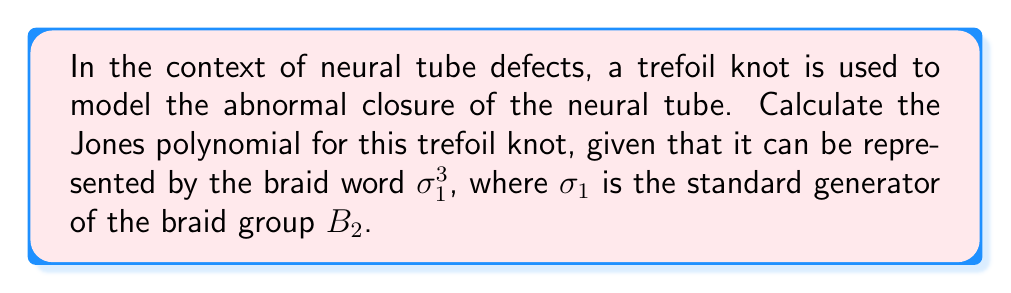Solve this math problem. To calculate the Jones polynomial for the trefoil knot representing neural tube defects, we'll follow these steps:

1) The trefoil knot is represented by the braid word $\sigma_1^3$. This means we're dealing with a 2-strand braid with 3 positive crossings.

2) The Jones polynomial can be calculated using the Kauffman bracket polynomial and the writhe of the knot. Let's start with the Kauffman bracket.

3) The Kauffman bracket of a positive crossing is given by:
   $$\langle \crossingpos \rangle = A\langle \smoothing \rangle + A^{-1}\langle \hsmoothing \rangle$$

4) For our trefoil with 3 positive crossings, we apply this relation three times:
   $$\langle \trefoil \rangle = A^3\langle \circle \rangle + A\langle \infty \rangle + A^{-1}\langle \infty \rangle + A^{-3}\langle \circle \circle \rangle$$

5) Simplify using the rules $\langle \circle \rangle = -A^2 - A^{-2}$ and $\langle \circle \circle \rangle = (-A^2 - A^{-2})^2$:
   $$\langle \trefoil \rangle = A^3(-A^2 - A^{-2}) + A(-A^2 - A^{-2}) + A^{-1}(-A^2 - A^{-2}) + A^{-3}(-A^2 - A^{-2})^2$$

6) Simplify further:
   $$\langle \trefoil \rangle = -A^5 - A^{-1} - A^3 - A^{-3} - A - A^{-5} + A^{-3}(A^4 + 2 + A^{-4})$$
   $$= -A^5 + A^{-3} + A^{-7}$$

7) The writhe of the trefoil knot is 3 (3 positive crossings).

8) The Jones polynomial is related to the Kauffman bracket by:
   $$V(t) = (-A^3)^{-\text{writhe}} \langle K \rangle|_{A = t^{-1/4}}$$

9) Substituting our results:
   $$V(t) = (-A^3)^{-3} (-A^5 + A^{-3} + A^{-7})|_{A = t^{-1/4}}$$
   $$= -A^{-9} (-A^5 + A^{-3} + A^{-7})|_{A = t^{-1/4}}$$
   $$= (t^{1/4})^9 (-(t^{-1/4})^5 + (t^{-1/4})^{-3} + (t^{-1/4})^{-7})$$
   $$= t^{9/4} (-t^{-5/4} + t^{3/4} + t^{7/4})$$
   $$= -t^{-1} + t^{-3} + t^{-4}$$

This is the Jones polynomial for the trefoil knot representing neural tube defects.
Answer: $V(t) = -t^{-1} + t^{-3} + t^{-4}$ 